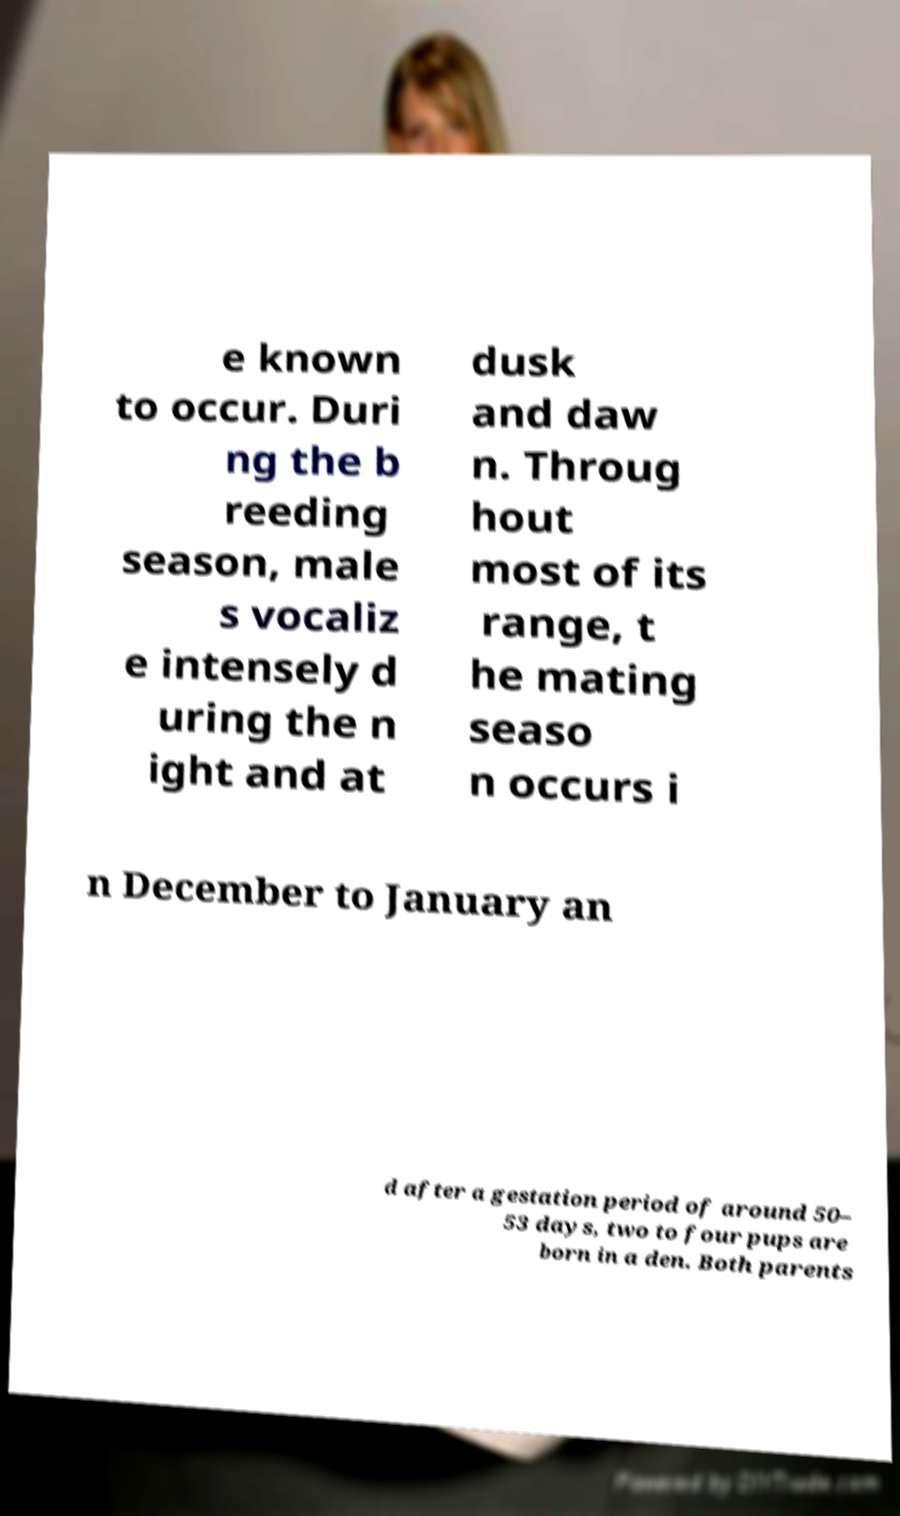For documentation purposes, I need the text within this image transcribed. Could you provide that? e known to occur. Duri ng the b reeding season, male s vocaliz e intensely d uring the n ight and at dusk and daw n. Throug hout most of its range, t he mating seaso n occurs i n December to January an d after a gestation period of around 50– 53 days, two to four pups are born in a den. Both parents 